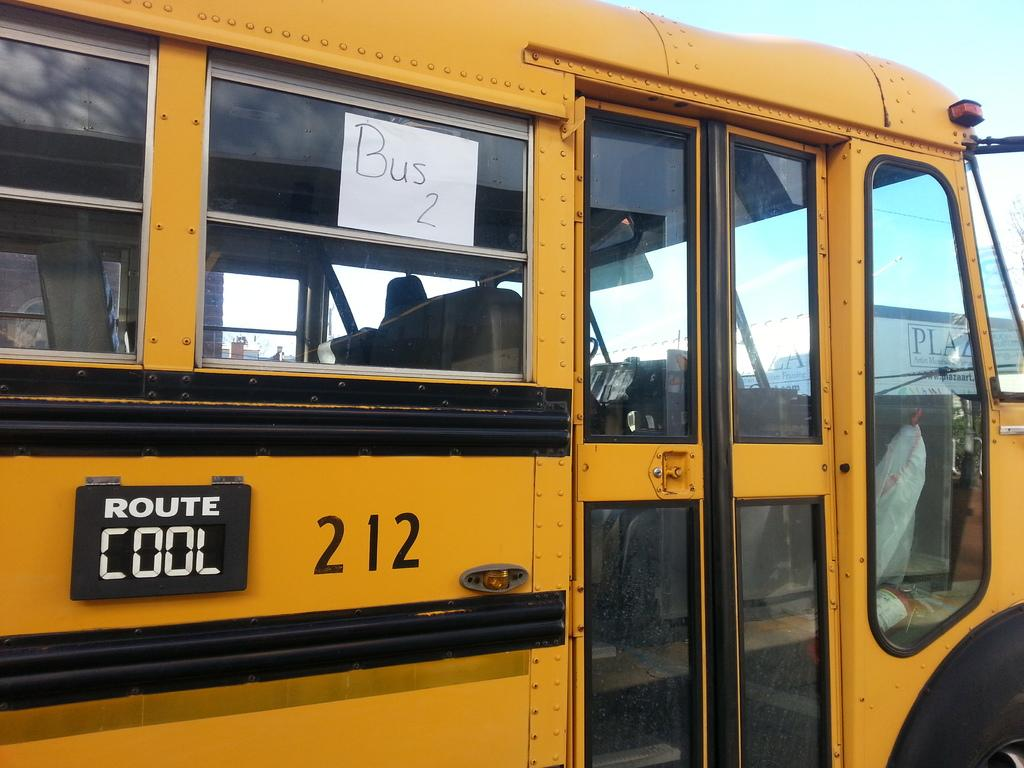Provide a one-sentence caption for the provided image. A yellow school bus that has the words route cool 212 on it. 